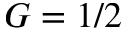<formula> <loc_0><loc_0><loc_500><loc_500>G = 1 / 2</formula> 